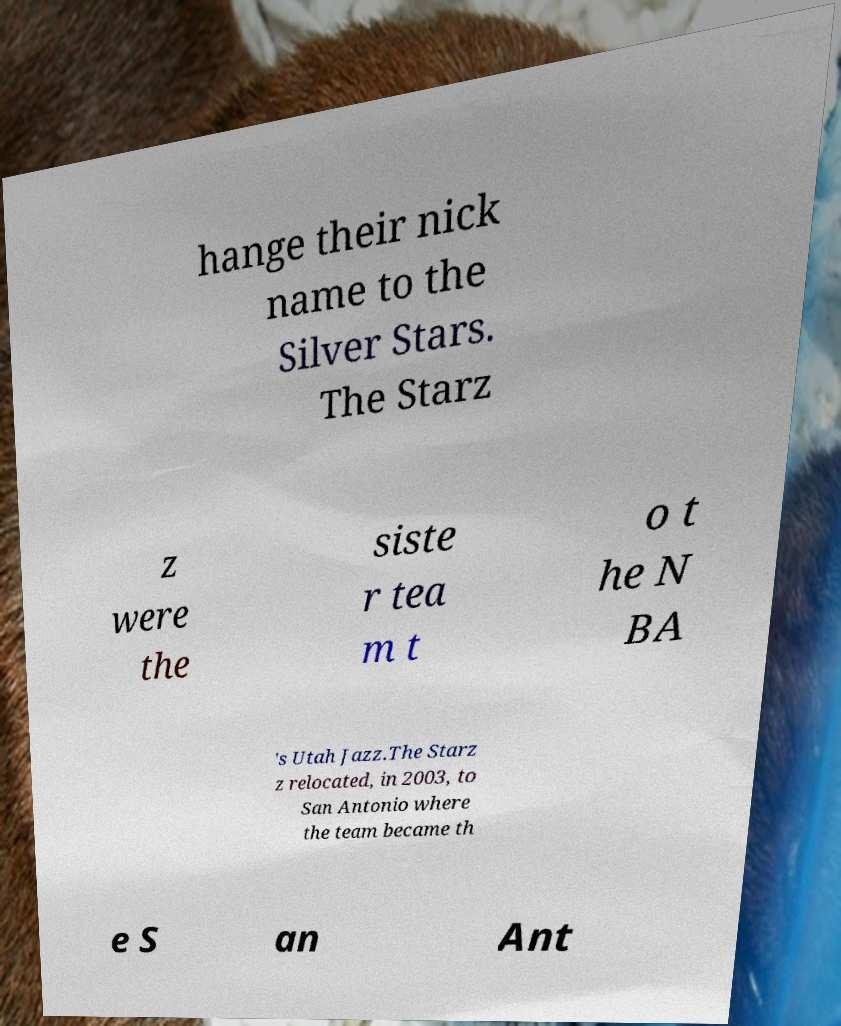I need the written content from this picture converted into text. Can you do that? hange their nick name to the Silver Stars. The Starz z were the siste r tea m t o t he N BA 's Utah Jazz.The Starz z relocated, in 2003, to San Antonio where the team became th e S an Ant 